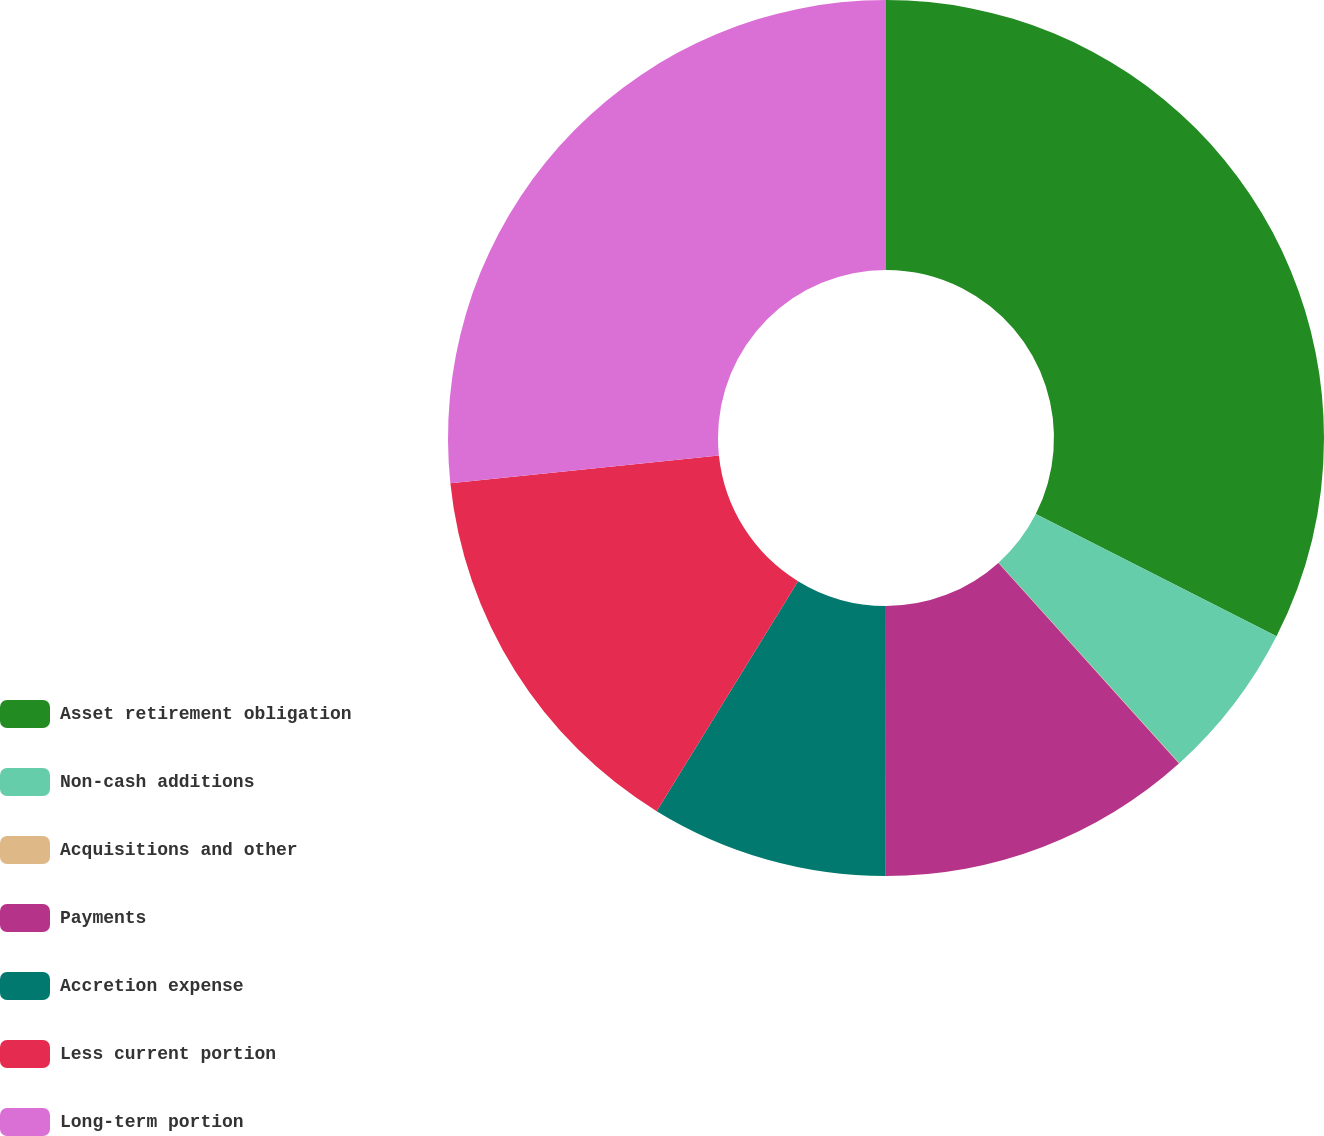Convert chart. <chart><loc_0><loc_0><loc_500><loc_500><pie_chart><fcel>Asset retirement obligation<fcel>Non-cash additions<fcel>Acquisitions and other<fcel>Payments<fcel>Accretion expense<fcel>Less current portion<fcel>Long-term portion<nl><fcel>32.48%<fcel>5.84%<fcel>0.02%<fcel>11.67%<fcel>8.76%<fcel>14.58%<fcel>26.65%<nl></chart> 